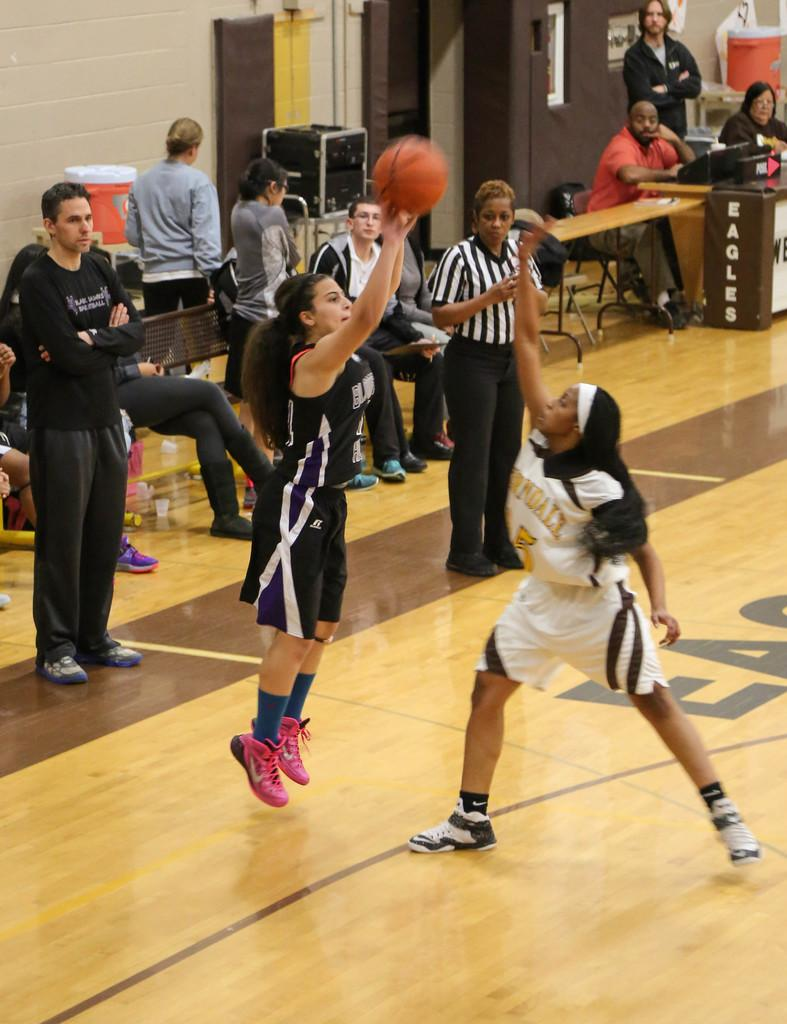What are the women in the image doing? The women in the center of the image are playing. Where are the women playing? The women are playing on the ground. What can be seen in the background of the image? In the background, there are speakers, a table, chairs, a door, a window, and a wall. What type of clam is visible on the table in the image? There is no clam present on the table or anywhere else in the image. 